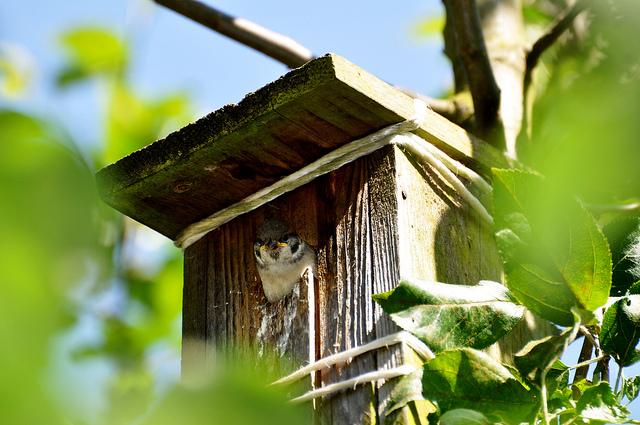Is this bird taking a bath?
Answer briefly. No. Are clouds visible?
Quick response, please. No. What is in the birdhouse?
Quick response, please. Bird. 